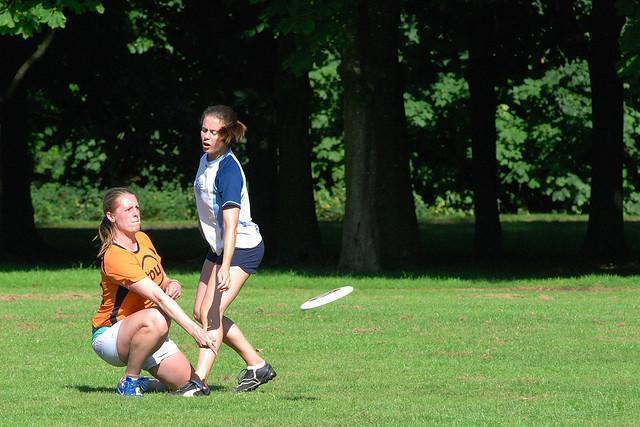How many people are there?
Give a very brief answer. 2. How many people can you see?
Give a very brief answer. 2. How many rolls of white toilet paper are in the bathroom?
Give a very brief answer. 0. 